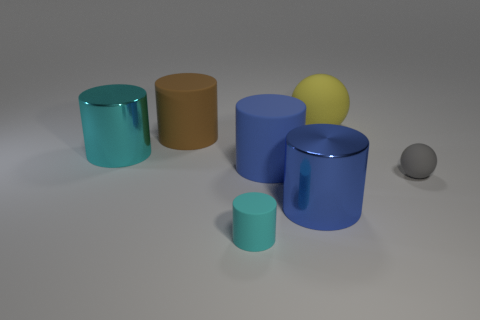What is the overall color scheme used in this image? The image features a muted, soft color palette predominantly composed of shades of blue and gray, with slight hints of yellow and brown providing a subtle contrast. 